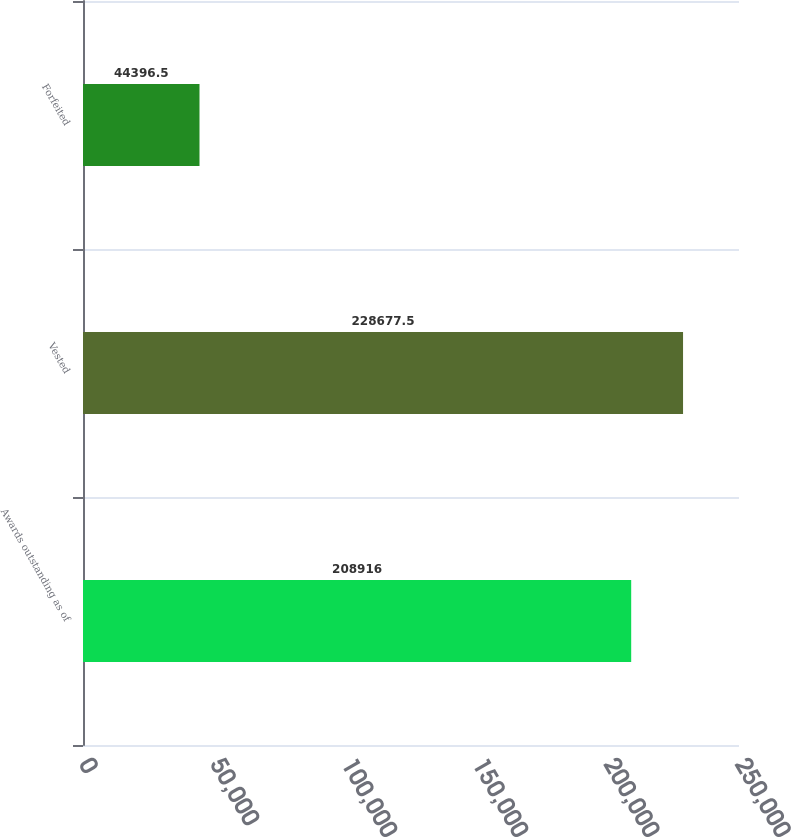<chart> <loc_0><loc_0><loc_500><loc_500><bar_chart><fcel>Awards outstanding as of<fcel>Vested<fcel>Forfeited<nl><fcel>208916<fcel>228678<fcel>44396.5<nl></chart> 